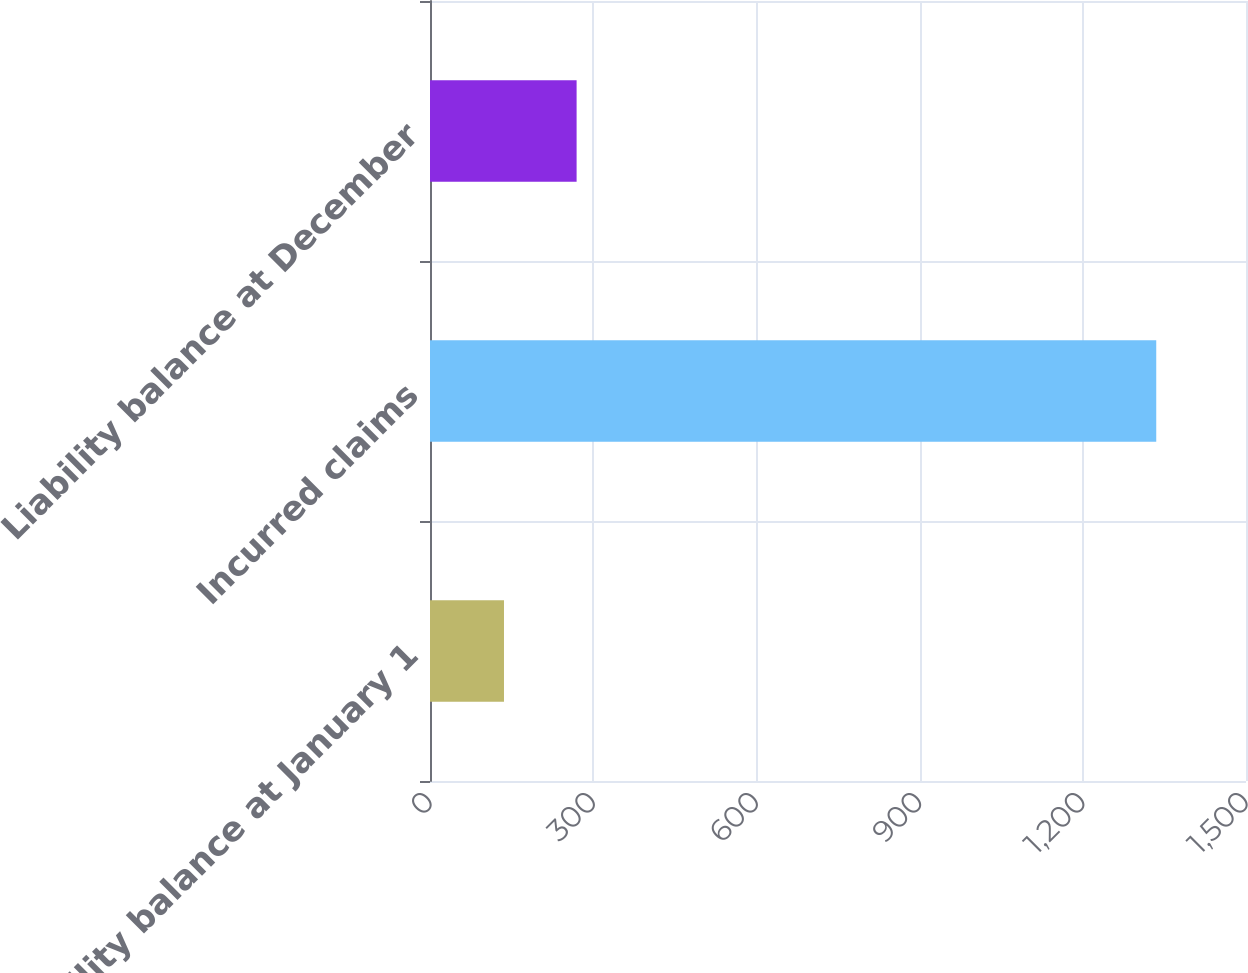Convert chart. <chart><loc_0><loc_0><loc_500><loc_500><bar_chart><fcel>Liability balance at January 1<fcel>Incurred claims<fcel>Liability balance at December<nl><fcel>136<fcel>1335<fcel>269.5<nl></chart> 